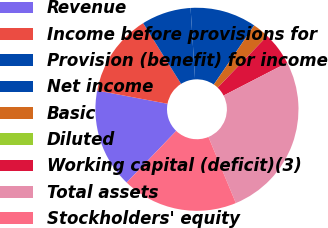Convert chart. <chart><loc_0><loc_0><loc_500><loc_500><pie_chart><fcel>Revenue<fcel>Income before provisions for<fcel>Provision (benefit) for income<fcel>Net income<fcel>Basic<fcel>Diluted<fcel>Working capital (deficit)(3)<fcel>Total assets<fcel>Stockholders' equity<nl><fcel>15.79%<fcel>13.16%<fcel>7.89%<fcel>10.53%<fcel>2.63%<fcel>0.0%<fcel>5.26%<fcel>26.32%<fcel>18.42%<nl></chart> 